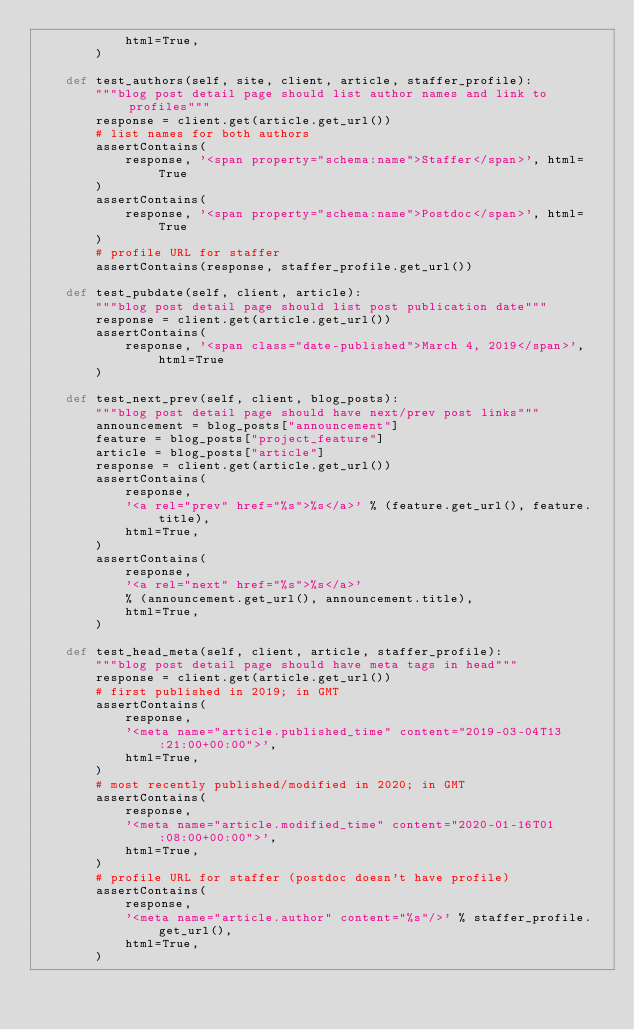Convert code to text. <code><loc_0><loc_0><loc_500><loc_500><_Python_>            html=True,
        )

    def test_authors(self, site, client, article, staffer_profile):
        """blog post detail page should list author names and link to profiles"""
        response = client.get(article.get_url())
        # list names for both authors
        assertContains(
            response, '<span property="schema:name">Staffer</span>', html=True
        )
        assertContains(
            response, '<span property="schema:name">Postdoc</span>', html=True
        )
        # profile URL for staffer
        assertContains(response, staffer_profile.get_url())

    def test_pubdate(self, client, article):
        """blog post detail page should list post publication date"""
        response = client.get(article.get_url())
        assertContains(
            response, '<span class="date-published">March 4, 2019</span>', html=True
        )

    def test_next_prev(self, client, blog_posts):
        """blog post detail page should have next/prev post links"""
        announcement = blog_posts["announcement"]
        feature = blog_posts["project_feature"]
        article = blog_posts["article"]
        response = client.get(article.get_url())
        assertContains(
            response,
            '<a rel="prev" href="%s">%s</a>' % (feature.get_url(), feature.title),
            html=True,
        )
        assertContains(
            response,
            '<a rel="next" href="%s">%s</a>'
            % (announcement.get_url(), announcement.title),
            html=True,
        )

    def test_head_meta(self, client, article, staffer_profile):
        """blog post detail page should have meta tags in head"""
        response = client.get(article.get_url())
        # first published in 2019; in GMT
        assertContains(
            response,
            '<meta name="article.published_time" content="2019-03-04T13:21:00+00:00">',
            html=True,
        )
        # most recently published/modified in 2020; in GMT
        assertContains(
            response,
            '<meta name="article.modified_time" content="2020-01-16T01:08:00+00:00">',
            html=True,
        )
        # profile URL for staffer (postdoc doesn't have profile)
        assertContains(
            response,
            '<meta name="article.author" content="%s"/>' % staffer_profile.get_url(),
            html=True,
        )
</code> 